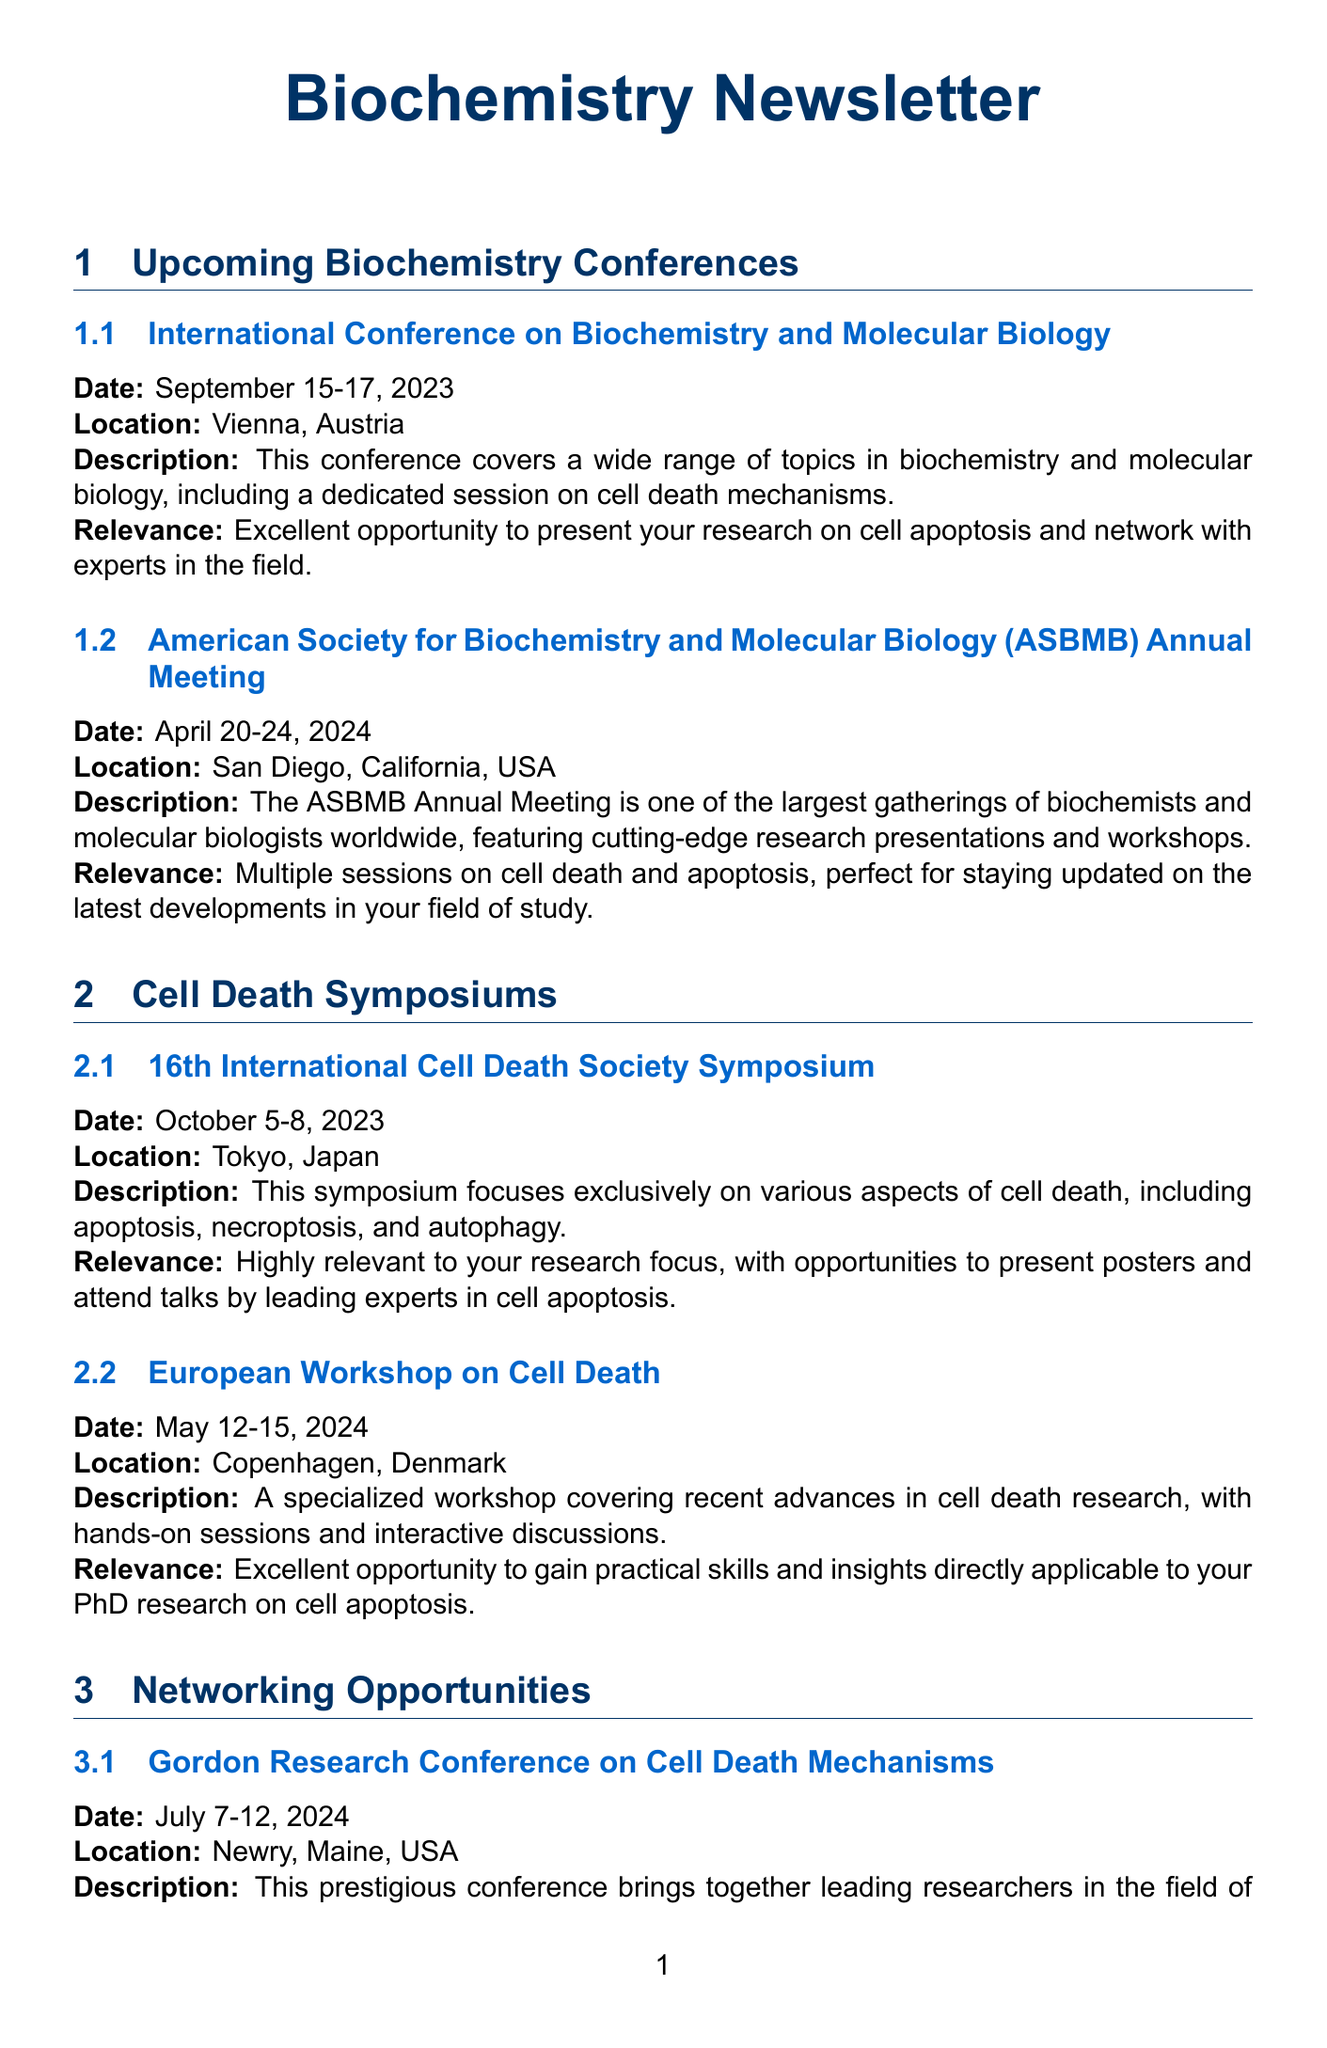What is the date of the International Conference on Biochemistry and Molecular Biology? The date is specified in the conference details as September 15-17, 2023.
Answer: September 15-17, 2023 Where is the 16th International Cell Death Society Symposium being held? The location of the symposium is mentioned in the document as Tokyo, Japan.
Answer: Tokyo, Japan What is the relevance of the EMBO Workshop on Mitochondria and Cell Death? The relevance highlights the opportunity to connect with researchers working on the mitochondrial aspects of apoptosis.
Answer: Great opportunity to connect with researchers working on the mitochondrial aspects of apoptosis When is the deadline for the ASBMB Travel Award? The document states the deadline as January 15, 2024.
Answer: January 15, 2024 Which event focuses exclusively on cell death mechanisms? The event mentioned is the 16th International Cell Death Society Symposium.
Answer: 16th International Cell Death Society Symposium What type of networking opportunities are available at the Gordon Research Conference on Cell Death Mechanisms? The conference offers in-depth discussions and collaborative opportunities among leading researchers.
Answer: In-depth discussions and collaborative opportunities How many days is the European Workshop on Cell Death scheduled for? The dates indicate that the workshop runs for four days, from May 12-15, 2024.
Answer: Four days What is the main focus of the ASBMB Annual Meeting? The focus of the meeting includes cutting-edge research presentations and workshops related to biochemistry and molecular biology.
Answer: Cutting-edge research presentations and workshops 